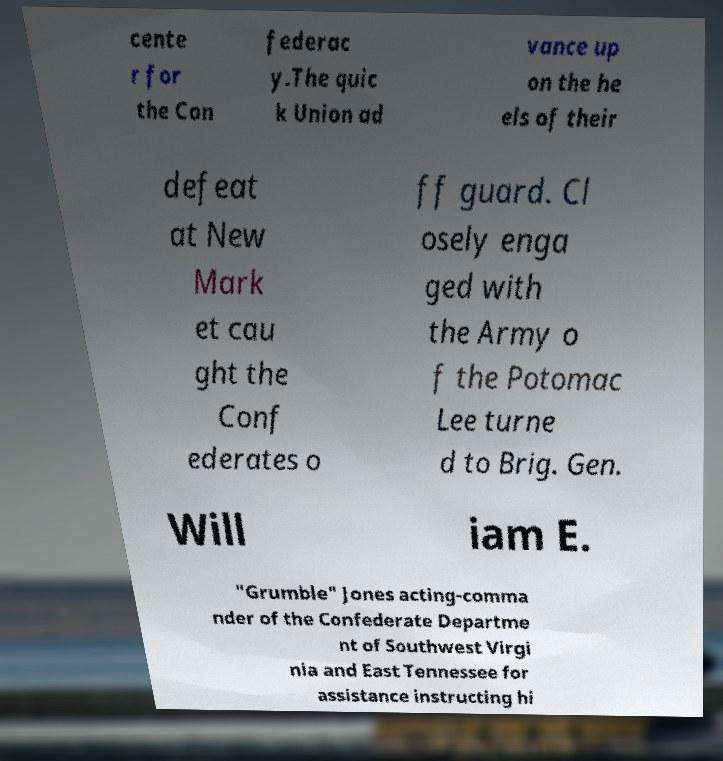Please identify and transcribe the text found in this image. cente r for the Con federac y.The quic k Union ad vance up on the he els of their defeat at New Mark et cau ght the Conf ederates o ff guard. Cl osely enga ged with the Army o f the Potomac Lee turne d to Brig. Gen. Will iam E. "Grumble" Jones acting-comma nder of the Confederate Departme nt of Southwest Virgi nia and East Tennessee for assistance instructing hi 